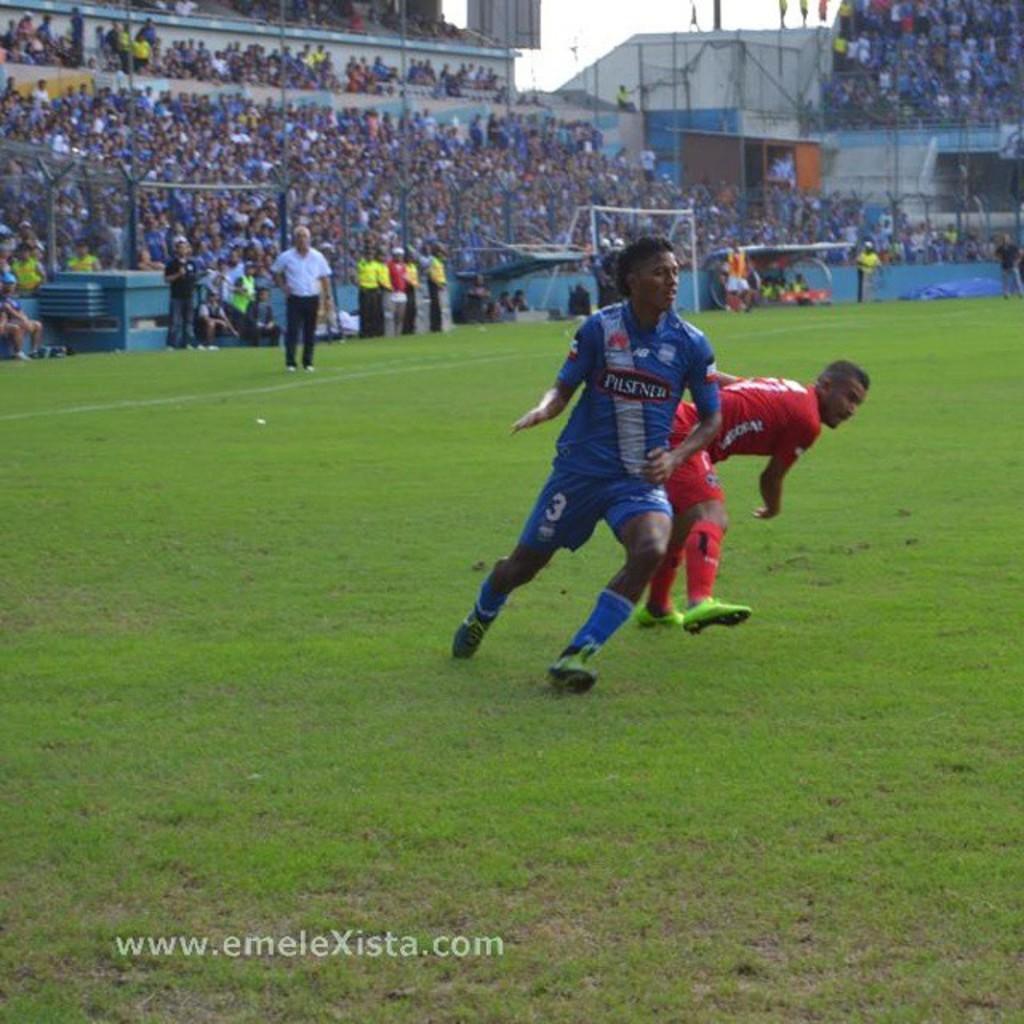How would you summarize this image in a sentence or two? In this image, there are a few people. Among them, some people are wearing T-shirts and shorts. We can see the ground covered with grass and some objects. We can also see some poles, a board and a tent. We can see the wall and the sky. We can also see some text written at the bottom. 